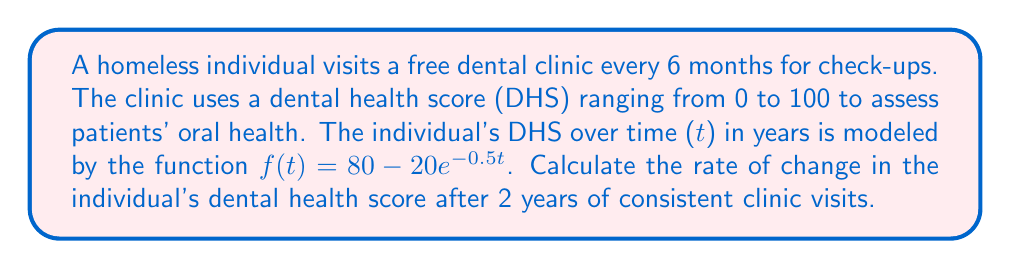Help me with this question. To find the rate of change in dental health score after 2 years, we need to calculate the derivative of the given function and evaluate it at t = 2.

1. The given function is $f(t) = 80 - 20e^{-0.5t}$

2. To find the derivative, we use the chain rule:
   $$\frac{d}{dt}[80 - 20e^{-0.5t}] = 0 - 20 \cdot \frac{d}{dt}[e^{-0.5t}]$$
   $$= -20 \cdot e^{-0.5t} \cdot (-0.5)$$
   $$= 10e^{-0.5t}$$

3. So, the derivative (rate of change) is $f'(t) = 10e^{-0.5t}$

4. To find the rate of change at t = 2, we evaluate $f'(2)$:
   $$f'(2) = 10e^{-0.5(2)}$$
   $$= 10e^{-1}$$
   $$= 10 \cdot \frac{1}{e}$$
   $$\approx 3.68$$

This means that after 2 years of consistent clinic visits, the individual's dental health score is improving at a rate of approximately 3.68 points per year.
Answer: $10e^{-1}$ or approximately 3.68 points per year 